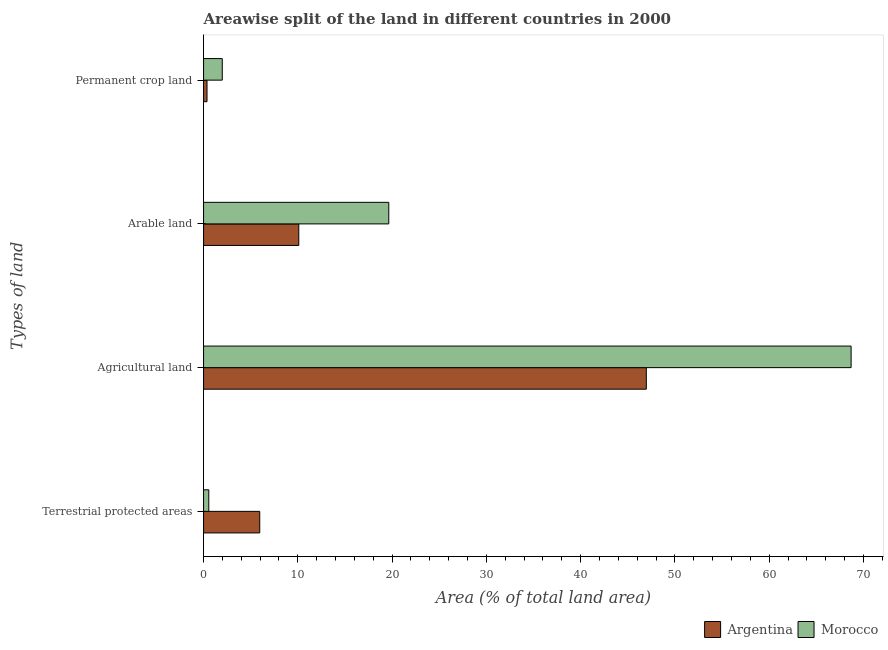How many different coloured bars are there?
Keep it short and to the point. 2. How many groups of bars are there?
Your response must be concise. 4. What is the label of the 2nd group of bars from the top?
Keep it short and to the point. Arable land. What is the percentage of land under terrestrial protection in Morocco?
Your answer should be very brief. 0.55. Across all countries, what is the maximum percentage of area under arable land?
Your response must be concise. 19.64. Across all countries, what is the minimum percentage of area under arable land?
Make the answer very short. 10.1. In which country was the percentage of area under agricultural land maximum?
Offer a terse response. Morocco. In which country was the percentage of area under agricultural land minimum?
Provide a short and direct response. Argentina. What is the total percentage of land under terrestrial protection in the graph?
Provide a succinct answer. 6.51. What is the difference between the percentage of area under agricultural land in Morocco and that in Argentina?
Offer a terse response. 21.72. What is the difference between the percentage of area under arable land in Argentina and the percentage of land under terrestrial protection in Morocco?
Provide a succinct answer. 9.55. What is the average percentage of land under terrestrial protection per country?
Your answer should be compact. 3.26. What is the difference between the percentage of land under terrestrial protection and percentage of area under arable land in Argentina?
Provide a short and direct response. -4.14. In how many countries, is the percentage of area under permanent crop land greater than 46 %?
Offer a terse response. 0. What is the ratio of the percentage of area under agricultural land in Argentina to that in Morocco?
Your answer should be compact. 0.68. Is the percentage of area under permanent crop land in Argentina less than that in Morocco?
Make the answer very short. Yes. What is the difference between the highest and the second highest percentage of area under agricultural land?
Give a very brief answer. 21.72. What is the difference between the highest and the lowest percentage of area under permanent crop land?
Your response must be concise. 1.62. What does the 2nd bar from the top in Arable land represents?
Offer a very short reply. Argentina. What does the 1st bar from the bottom in Terrestrial protected areas represents?
Ensure brevity in your answer.  Argentina. Are all the bars in the graph horizontal?
Keep it short and to the point. Yes. How many countries are there in the graph?
Your answer should be compact. 2. What is the difference between two consecutive major ticks on the X-axis?
Give a very brief answer. 10. Does the graph contain any zero values?
Keep it short and to the point. No. Does the graph contain grids?
Keep it short and to the point. No. Where does the legend appear in the graph?
Keep it short and to the point. Bottom right. How many legend labels are there?
Your answer should be compact. 2. What is the title of the graph?
Make the answer very short. Areawise split of the land in different countries in 2000. Does "Marshall Islands" appear as one of the legend labels in the graph?
Make the answer very short. No. What is the label or title of the X-axis?
Keep it short and to the point. Area (% of total land area). What is the label or title of the Y-axis?
Offer a terse response. Types of land. What is the Area (% of total land area) in Argentina in Terrestrial protected areas?
Give a very brief answer. 5.96. What is the Area (% of total land area) of Morocco in Terrestrial protected areas?
Keep it short and to the point. 0.55. What is the Area (% of total land area) of Argentina in Agricultural land?
Your response must be concise. 46.96. What is the Area (% of total land area) of Morocco in Agricultural land?
Provide a short and direct response. 68.68. What is the Area (% of total land area) of Argentina in Arable land?
Make the answer very short. 10.1. What is the Area (% of total land area) in Morocco in Arable land?
Make the answer very short. 19.64. What is the Area (% of total land area) of Argentina in Permanent crop land?
Your answer should be compact. 0.37. What is the Area (% of total land area) in Morocco in Permanent crop land?
Keep it short and to the point. 1.98. Across all Types of land, what is the maximum Area (% of total land area) in Argentina?
Your answer should be compact. 46.96. Across all Types of land, what is the maximum Area (% of total land area) in Morocco?
Provide a succinct answer. 68.68. Across all Types of land, what is the minimum Area (% of total land area) of Argentina?
Provide a succinct answer. 0.37. Across all Types of land, what is the minimum Area (% of total land area) in Morocco?
Give a very brief answer. 0.55. What is the total Area (% of total land area) in Argentina in the graph?
Offer a very short reply. 63.38. What is the total Area (% of total land area) of Morocco in the graph?
Offer a terse response. 90.86. What is the difference between the Area (% of total land area) in Argentina in Terrestrial protected areas and that in Agricultural land?
Ensure brevity in your answer.  -41. What is the difference between the Area (% of total land area) of Morocco in Terrestrial protected areas and that in Agricultural land?
Provide a short and direct response. -68.13. What is the difference between the Area (% of total land area) of Argentina in Terrestrial protected areas and that in Arable land?
Make the answer very short. -4.14. What is the difference between the Area (% of total land area) of Morocco in Terrestrial protected areas and that in Arable land?
Your answer should be very brief. -19.09. What is the difference between the Area (% of total land area) of Argentina in Terrestrial protected areas and that in Permanent crop land?
Keep it short and to the point. 5.59. What is the difference between the Area (% of total land area) in Morocco in Terrestrial protected areas and that in Permanent crop land?
Keep it short and to the point. -1.43. What is the difference between the Area (% of total land area) in Argentina in Agricultural land and that in Arable land?
Provide a succinct answer. 36.86. What is the difference between the Area (% of total land area) of Morocco in Agricultural land and that in Arable land?
Provide a succinct answer. 49.04. What is the difference between the Area (% of total land area) in Argentina in Agricultural land and that in Permanent crop land?
Your answer should be compact. 46.59. What is the difference between the Area (% of total land area) in Morocco in Agricultural land and that in Permanent crop land?
Offer a very short reply. 66.7. What is the difference between the Area (% of total land area) of Argentina in Arable land and that in Permanent crop land?
Keep it short and to the point. 9.73. What is the difference between the Area (% of total land area) of Morocco in Arable land and that in Permanent crop land?
Provide a short and direct response. 17.66. What is the difference between the Area (% of total land area) of Argentina in Terrestrial protected areas and the Area (% of total land area) of Morocco in Agricultural land?
Offer a very short reply. -62.72. What is the difference between the Area (% of total land area) of Argentina in Terrestrial protected areas and the Area (% of total land area) of Morocco in Arable land?
Ensure brevity in your answer.  -13.69. What is the difference between the Area (% of total land area) of Argentina in Terrestrial protected areas and the Area (% of total land area) of Morocco in Permanent crop land?
Your answer should be very brief. 3.98. What is the difference between the Area (% of total land area) of Argentina in Agricultural land and the Area (% of total land area) of Morocco in Arable land?
Your answer should be compact. 27.31. What is the difference between the Area (% of total land area) of Argentina in Agricultural land and the Area (% of total land area) of Morocco in Permanent crop land?
Your answer should be very brief. 44.98. What is the difference between the Area (% of total land area) in Argentina in Arable land and the Area (% of total land area) in Morocco in Permanent crop land?
Give a very brief answer. 8.12. What is the average Area (% of total land area) of Argentina per Types of land?
Offer a very short reply. 15.85. What is the average Area (% of total land area) of Morocco per Types of land?
Provide a succinct answer. 22.72. What is the difference between the Area (% of total land area) in Argentina and Area (% of total land area) in Morocco in Terrestrial protected areas?
Ensure brevity in your answer.  5.4. What is the difference between the Area (% of total land area) of Argentina and Area (% of total land area) of Morocco in Agricultural land?
Keep it short and to the point. -21.72. What is the difference between the Area (% of total land area) in Argentina and Area (% of total land area) in Morocco in Arable land?
Offer a terse response. -9.54. What is the difference between the Area (% of total land area) in Argentina and Area (% of total land area) in Morocco in Permanent crop land?
Provide a short and direct response. -1.62. What is the ratio of the Area (% of total land area) in Argentina in Terrestrial protected areas to that in Agricultural land?
Your answer should be compact. 0.13. What is the ratio of the Area (% of total land area) of Morocco in Terrestrial protected areas to that in Agricultural land?
Give a very brief answer. 0.01. What is the ratio of the Area (% of total land area) of Argentina in Terrestrial protected areas to that in Arable land?
Make the answer very short. 0.59. What is the ratio of the Area (% of total land area) of Morocco in Terrestrial protected areas to that in Arable land?
Give a very brief answer. 0.03. What is the ratio of the Area (% of total land area) in Argentina in Terrestrial protected areas to that in Permanent crop land?
Make the answer very short. 16.31. What is the ratio of the Area (% of total land area) in Morocco in Terrestrial protected areas to that in Permanent crop land?
Offer a terse response. 0.28. What is the ratio of the Area (% of total land area) in Argentina in Agricultural land to that in Arable land?
Provide a succinct answer. 4.65. What is the ratio of the Area (% of total land area) in Morocco in Agricultural land to that in Arable land?
Offer a very short reply. 3.5. What is the ratio of the Area (% of total land area) in Argentina in Agricultural land to that in Permanent crop land?
Your answer should be very brief. 128.51. What is the ratio of the Area (% of total land area) in Morocco in Agricultural land to that in Permanent crop land?
Provide a short and direct response. 34.63. What is the ratio of the Area (% of total land area) in Argentina in Arable land to that in Permanent crop land?
Keep it short and to the point. 27.64. What is the ratio of the Area (% of total land area) in Morocco in Arable land to that in Permanent crop land?
Your response must be concise. 9.91. What is the difference between the highest and the second highest Area (% of total land area) of Argentina?
Offer a terse response. 36.86. What is the difference between the highest and the second highest Area (% of total land area) of Morocco?
Keep it short and to the point. 49.04. What is the difference between the highest and the lowest Area (% of total land area) of Argentina?
Provide a succinct answer. 46.59. What is the difference between the highest and the lowest Area (% of total land area) of Morocco?
Provide a short and direct response. 68.13. 